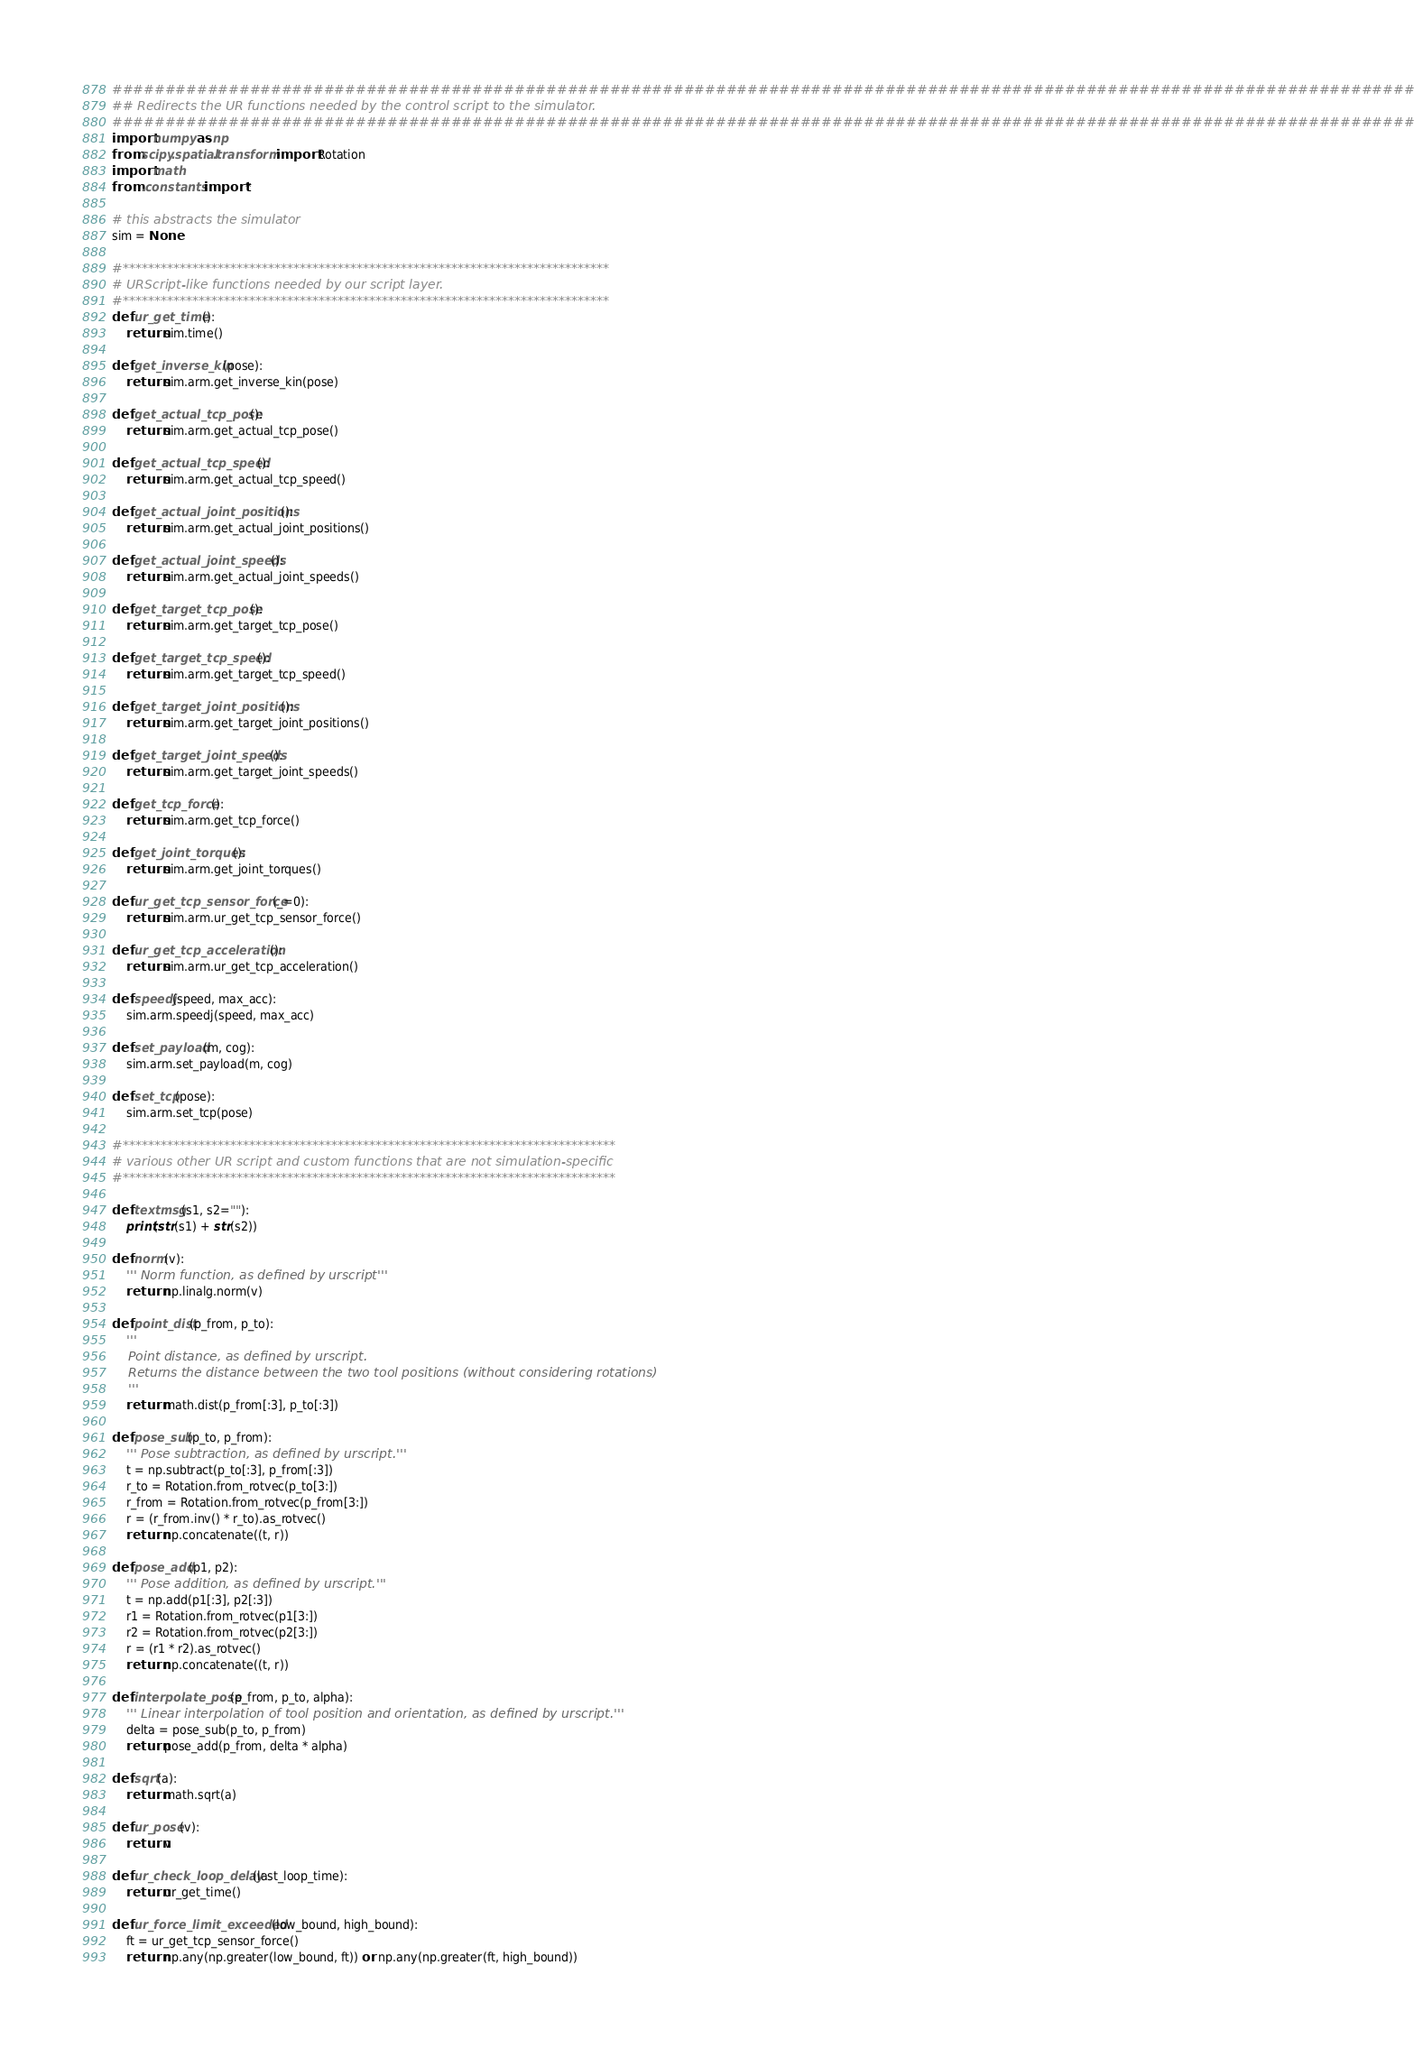<code> <loc_0><loc_0><loc_500><loc_500><_Python_>################################################################################################################################
## Redirects the UR functions needed by the control script to the simulator.
################################################################################################################################
import numpy as np
from scipy.spatial.transform import Rotation
import math
from .constants import *

# this abstracts the simulator
sim = None

#*****************************************************************************
# URScript-like functions needed by our script layer.
#*****************************************************************************
def ur_get_time():
    return sim.time()

def get_inverse_kin(pose):
    return sim.arm.get_inverse_kin(pose)

def get_actual_tcp_pose():
    return sim.arm.get_actual_tcp_pose()

def get_actual_tcp_speed():
    return sim.arm.get_actual_tcp_speed()

def get_actual_joint_positions():
    return sim.arm.get_actual_joint_positions()

def get_actual_joint_speeds():
    return sim.arm.get_actual_joint_speeds()

def get_target_tcp_pose():
    return sim.arm.get_target_tcp_pose()

def get_target_tcp_speed():
    return sim.arm.get_target_tcp_speed()

def get_target_joint_positions():
    return sim.arm.get_target_joint_positions()

def get_target_joint_speeds():
    return sim.arm.get_target_joint_speeds()

def get_tcp_force():
    return sim.arm.get_tcp_force()

def get_joint_torques():
    return sim.arm.get_joint_torques()

def ur_get_tcp_sensor_force(_=0):
    return sim.arm.ur_get_tcp_sensor_force()

def ur_get_tcp_acceleration():
    return sim.arm.ur_get_tcp_acceleration()

def speedj(speed, max_acc):
    sim.arm.speedj(speed, max_acc)

def set_payload(m, cog):
    sim.arm.set_payload(m, cog)

def set_tcp(pose):
    sim.arm.set_tcp(pose)

#******************************************************************************
# various other UR script and custom functions that are not simulation-specific
#******************************************************************************

def textmsg(s1, s2=""):
    print(str(s1) + str(s2))

def norm(v):
    ''' Norm function, as defined by urscript'''
    return np.linalg.norm(v)

def point_dist(p_from, p_to):
    '''
    Point distance, as defined by urscript.
    Returns the distance between the two tool positions (without considering rotations)
    '''
    return math.dist(p_from[:3], p_to[:3])

def pose_sub(p_to, p_from):
    ''' Pose subtraction, as defined by urscript.'''
    t = np.subtract(p_to[:3], p_from[:3])
    r_to = Rotation.from_rotvec(p_to[3:])
    r_from = Rotation.from_rotvec(p_from[3:])
    r = (r_from.inv() * r_to).as_rotvec()
    return np.concatenate((t, r))

def pose_add(p1, p2):
    ''' Pose addition, as defined by urscript.'''
    t = np.add(p1[:3], p2[:3])
    r1 = Rotation.from_rotvec(p1[3:])
    r2 = Rotation.from_rotvec(p2[3:])
    r = (r1 * r2).as_rotvec()
    return np.concatenate((t, r))

def interpolate_pose(p_from, p_to, alpha):
    ''' Linear interpolation of tool position and orientation, as defined by urscript.'''
    delta = pose_sub(p_to, p_from)
    return pose_add(p_from, delta * alpha)

def sqrt(a):
    return math.sqrt(a)

def ur_pose(v):
    return v

def ur_check_loop_delay(last_loop_time):
    return ur_get_time()

def ur_force_limit_exceeded(low_bound, high_bound):
    ft = ur_get_tcp_sensor_force()
    return np.any(np.greater(low_bound, ft)) or np.any(np.greater(ft, high_bound))

</code> 